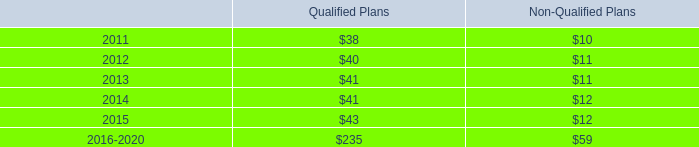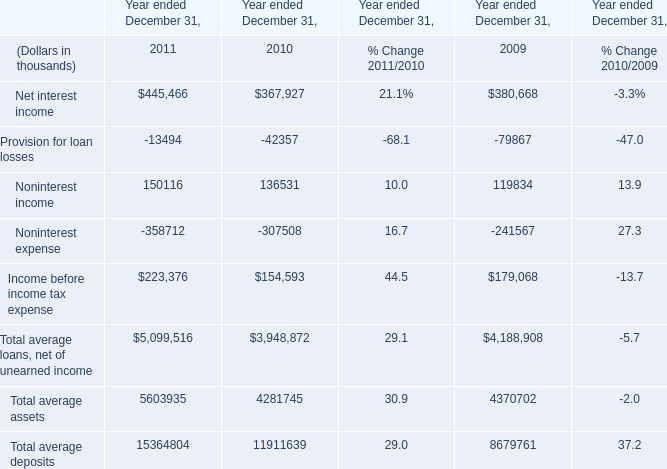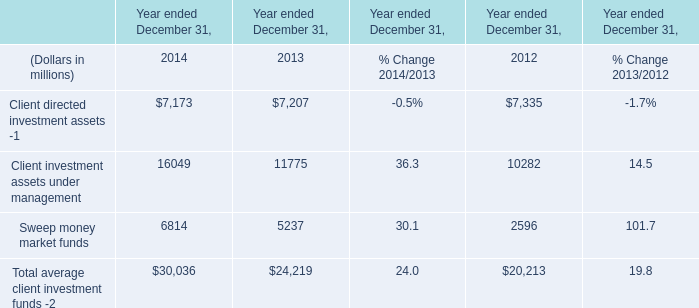As As the chart 1 shows, for Year ended December 31,which year is the value of the Income before income tax expense the highest? 
Answer: 2011. 